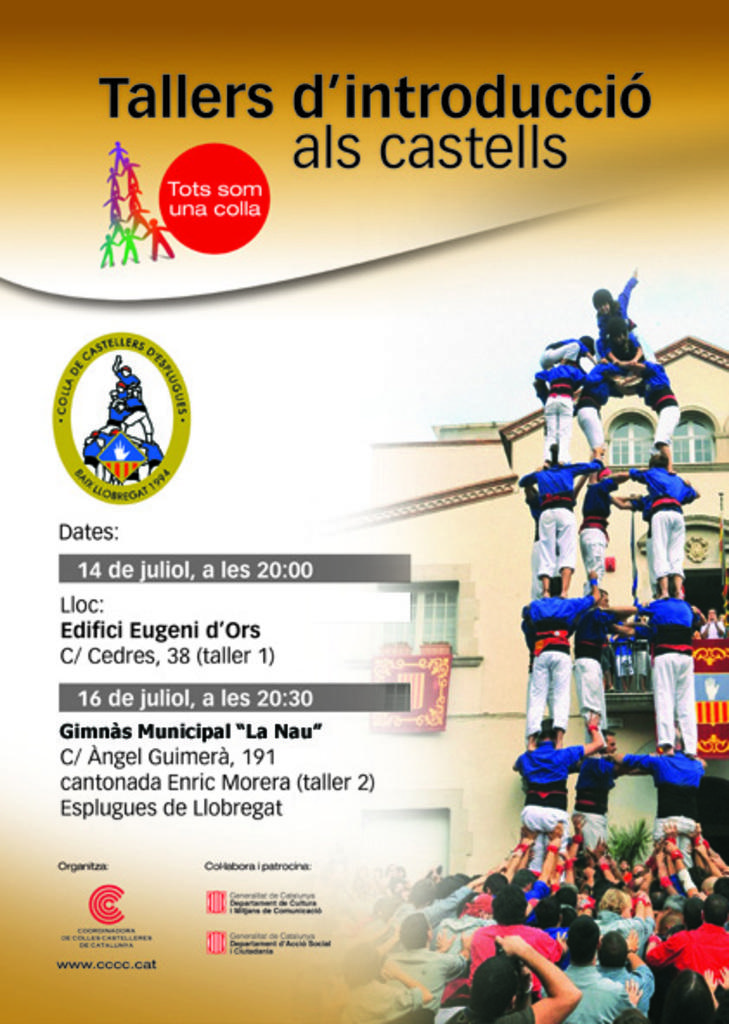What is featured on the poster in the image? The poster contains names, text, and logos. Can you describe the pictures on the right side of the image? There are pictures of people on the right side of the image. What type of cloth is being washed in the image? There is no cloth or washing activity present in the image. How many trees are visible in the image? There are no trees visible in the image. 